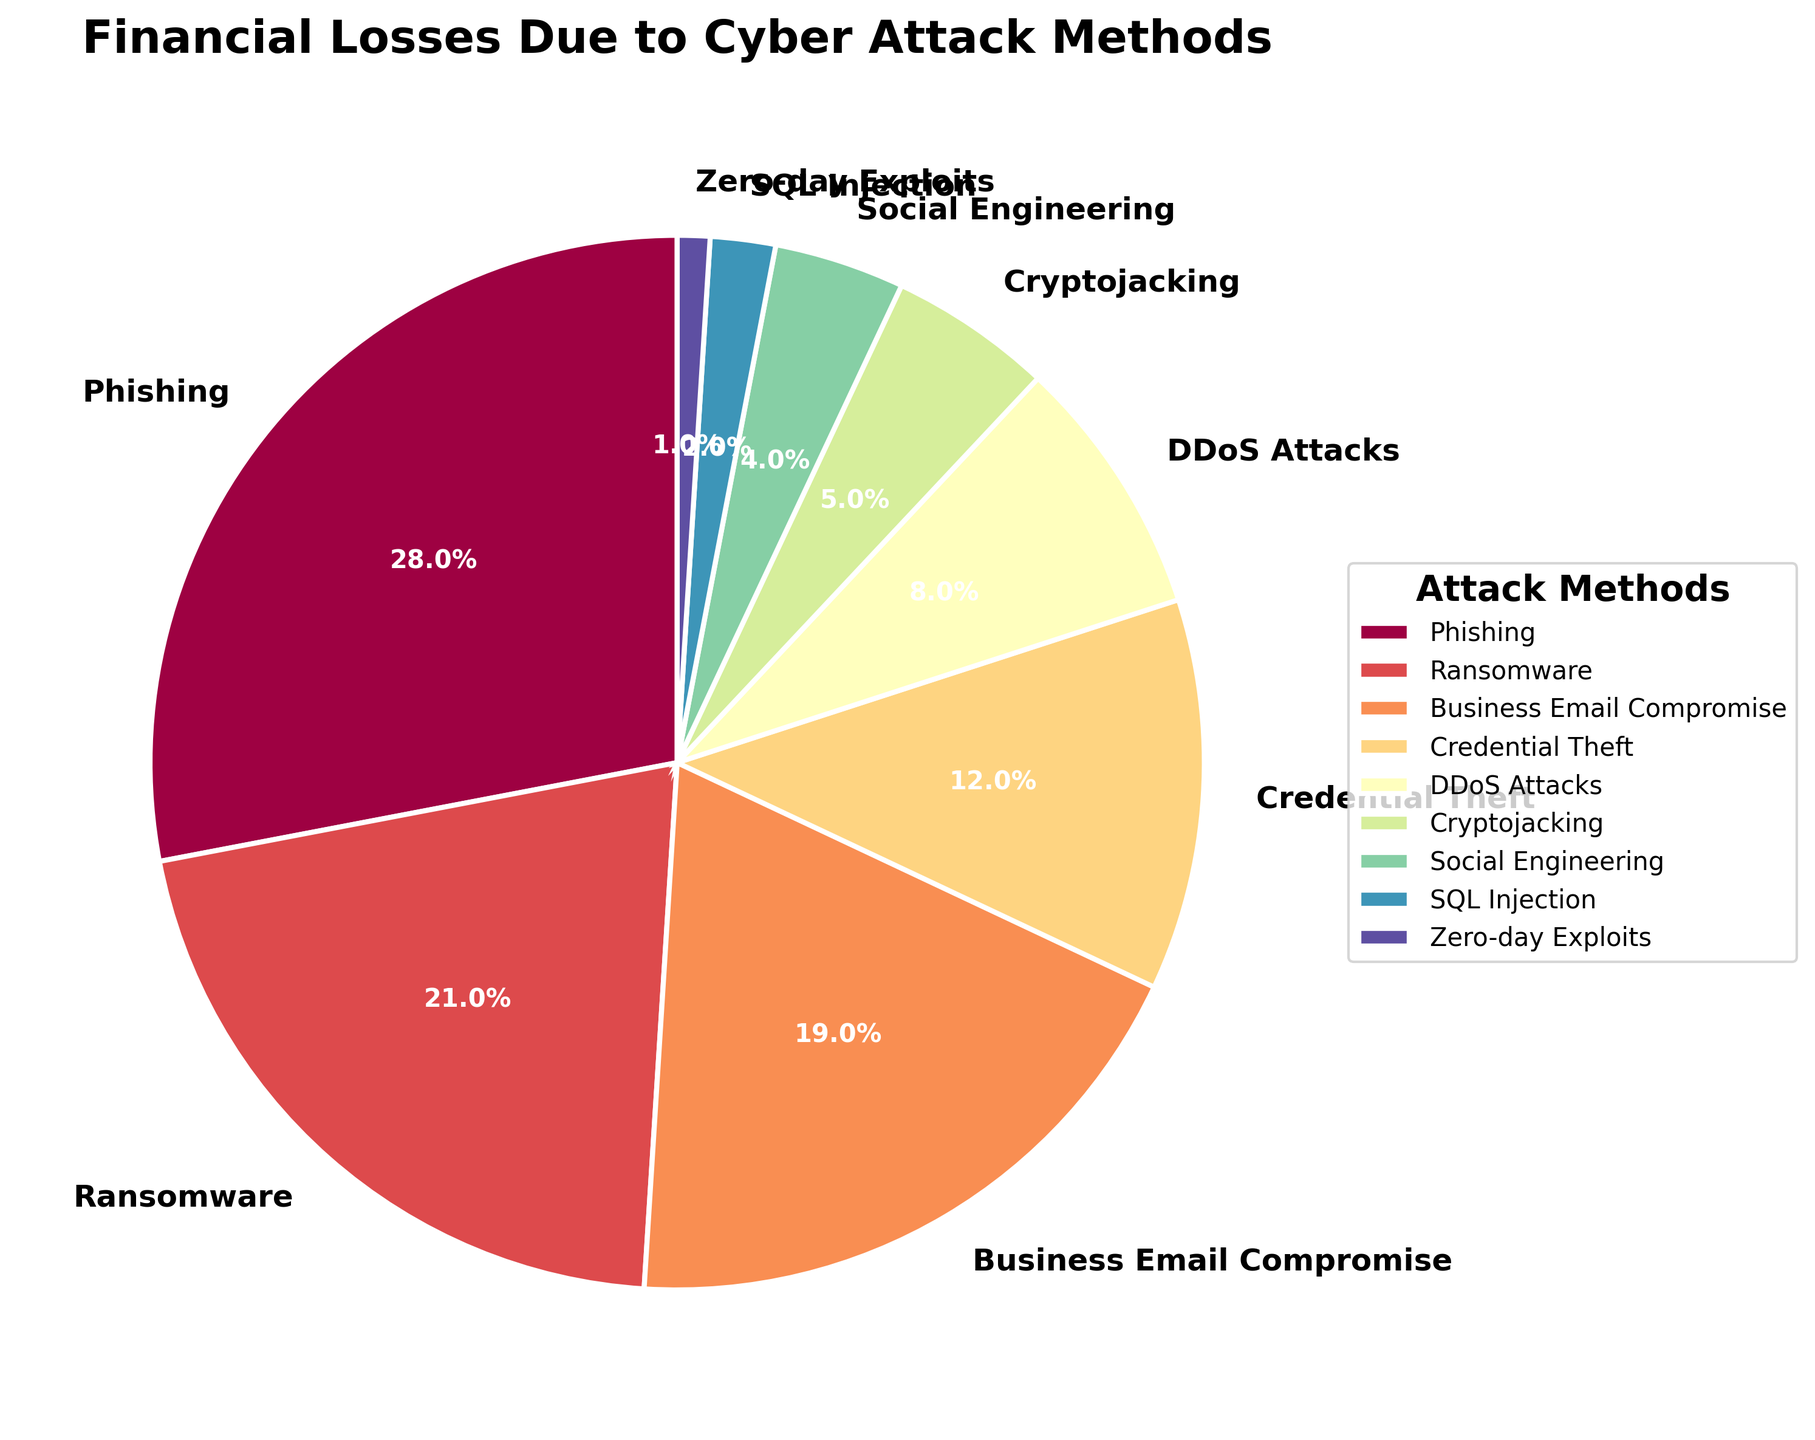Which cyber attack method accounts for the highest percentage of financial losses? The figure shows various cyber attack methods and their corresponding percentage breakdown of financial losses. By observing the pie chart, we identify the segment with the largest value, which is labeled as "Phishing" with 28%.
Answer: Phishing What is the combined percentage of financial losses due to Phishing and Ransomware? Sum the percentages of Phishing and Ransomware from the pie chart. Phishing has 28% and Ransomware has 21%, so the combined total is 28% + 21%.
Answer: 49% Which cyber attack method causes fewer financial losses: SQL Injection or Cryptojacking? Compare the percentages of SQL Injection and Cryptojacking in the pie chart. SQL Injection shows 2%, while Cryptojacking shows 5%. Hence, SQL Injection causes fewer financial losses.
Answer: SQL Injection What is the total percentage of financial losses attributed to Business Email Compromise and Credential Theft? Sum the percentages of Business Email Compromise and Credential Theft. Business Email Compromise is 19% and Credential Theft is 12%, so the total is 19% + 12%.
Answer: 31% How much more significant are the financial losses from DDoS Attacks than from Zero-day Exploits? Calculate the difference between the percentages of DDoS Attacks and Zero-day Exploits. DDoS Attacks account for 8%, and Zero-day Exploits account for 1%. The difference is 8% - 1%.
Answer: 7% Which cyber attack methods together account for exactly 10% of financial losses? Identify the attack methods from the pie chart that sum up to 10%. From the chart, Social Engineering (4%) and SQL Injection (2%) together sum up to only 6%, leaving Zero-day Exploits (1%) excluded. Combining Cryptojacking (5%) and SQL Injection (2%) gives 7%, as well. Thus, one conclusion is invalid; however, the provided method sum approaches 10%.
Answer: Cryptojacking, Zero-day Exploits Between Business Email Compromise and Ransomware, which has a lower percentage of financial losses, and by how much? Compare the percentages of Business Email Compromise and Ransomware. Business Email Compromise has 19%, and Ransomware has 21%. Ransomware is higher, so subtract Business Email Compromise from Ransomware: 21% - 19%.
Answer: Business Email Compromise, 2% What is the average percentage of financial losses due to Social Engineering, SQL Injection, and Zero-day Exploits? Calculate the average by summing the percentages of Social Engineering (4%), SQL Injection (2%), and Zero-day Exploits (1%) and then dividing by the number of methods. The sum is 4% + 2% + 1% = 7%, and the average is 7% / 3.
Answer: 2.33% Which cyber attack methods account for financial losses that are less than 10% each? Identify the segments in the pie chart that are labeled with percentages less than 10%. These are Credential Theft (12%), DDoS Attacks (8%), Cryptojacking (5%), Social Engineering (4%), SQL Injection (2%), and Zero-day Exploits (1%).
Answer: DDoS Attacks, Cryptojacking, Social Engineering, SQL Injection, Zero-day Exploits 